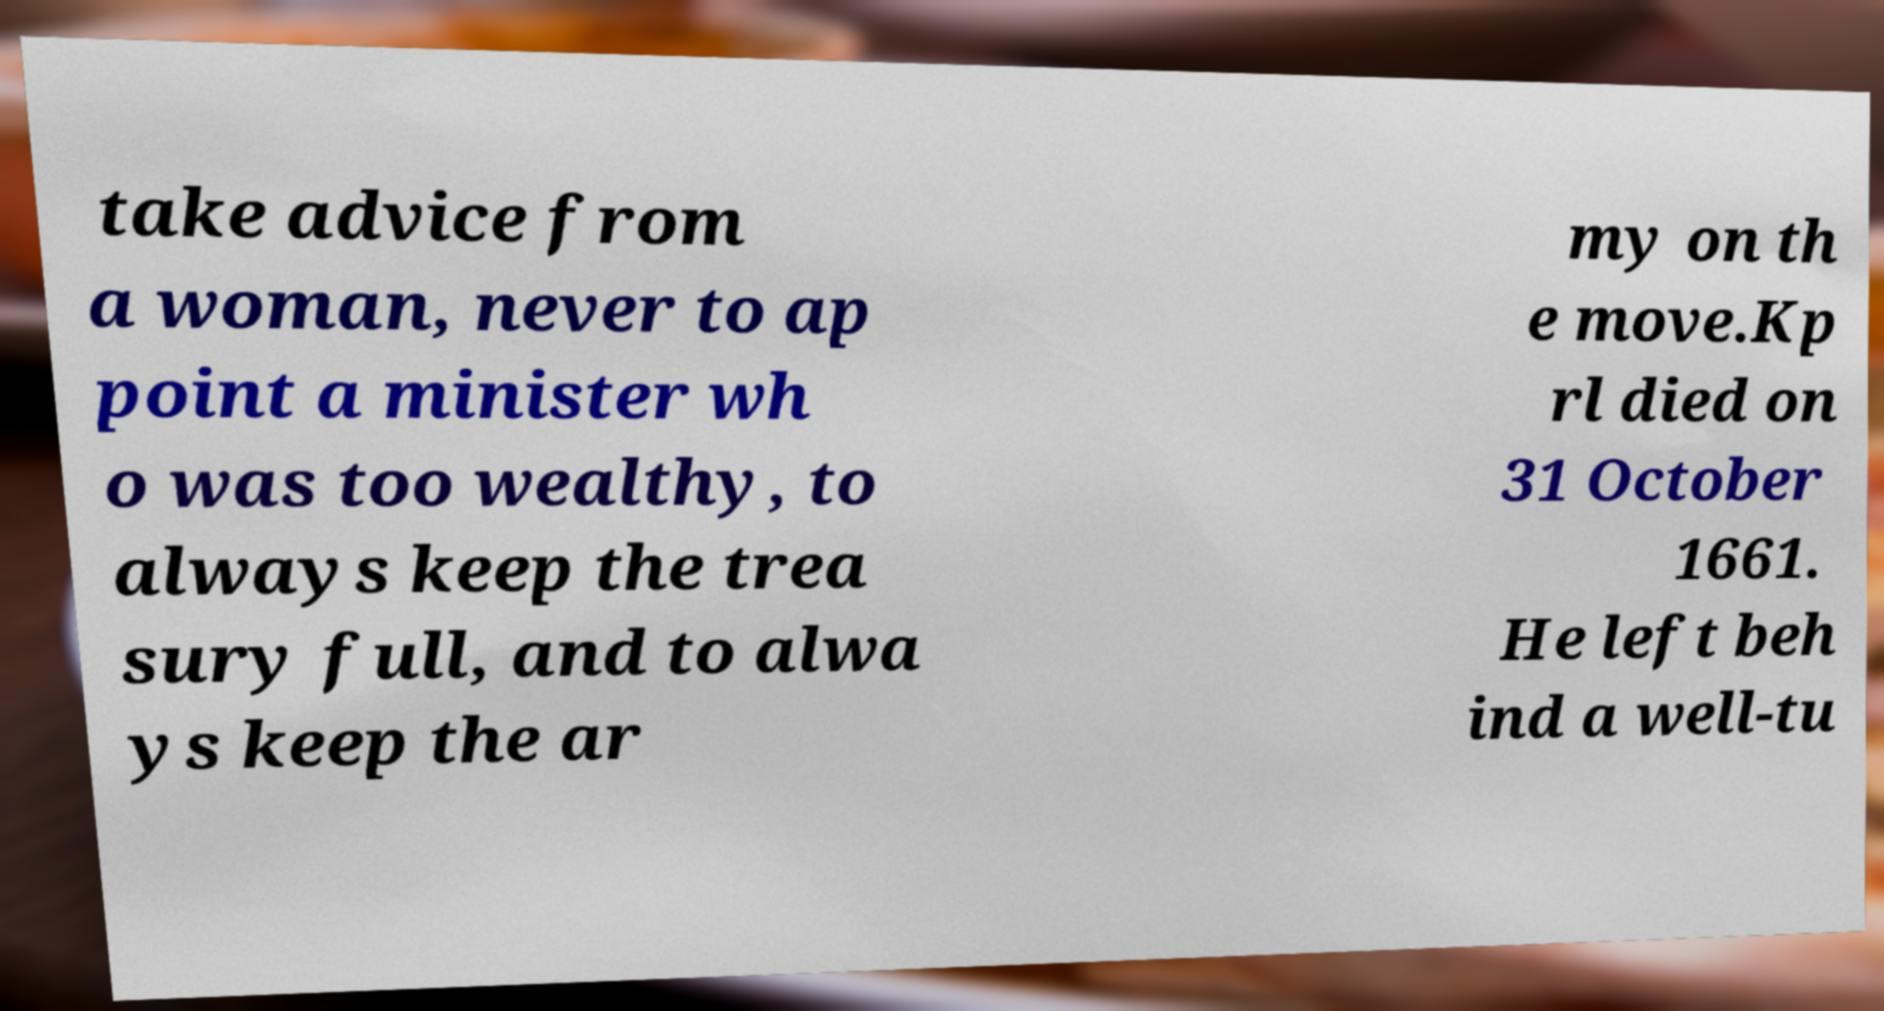Can you accurately transcribe the text from the provided image for me? take advice from a woman, never to ap point a minister wh o was too wealthy, to always keep the trea sury full, and to alwa ys keep the ar my on th e move.Kp rl died on 31 October 1661. He left beh ind a well-tu 